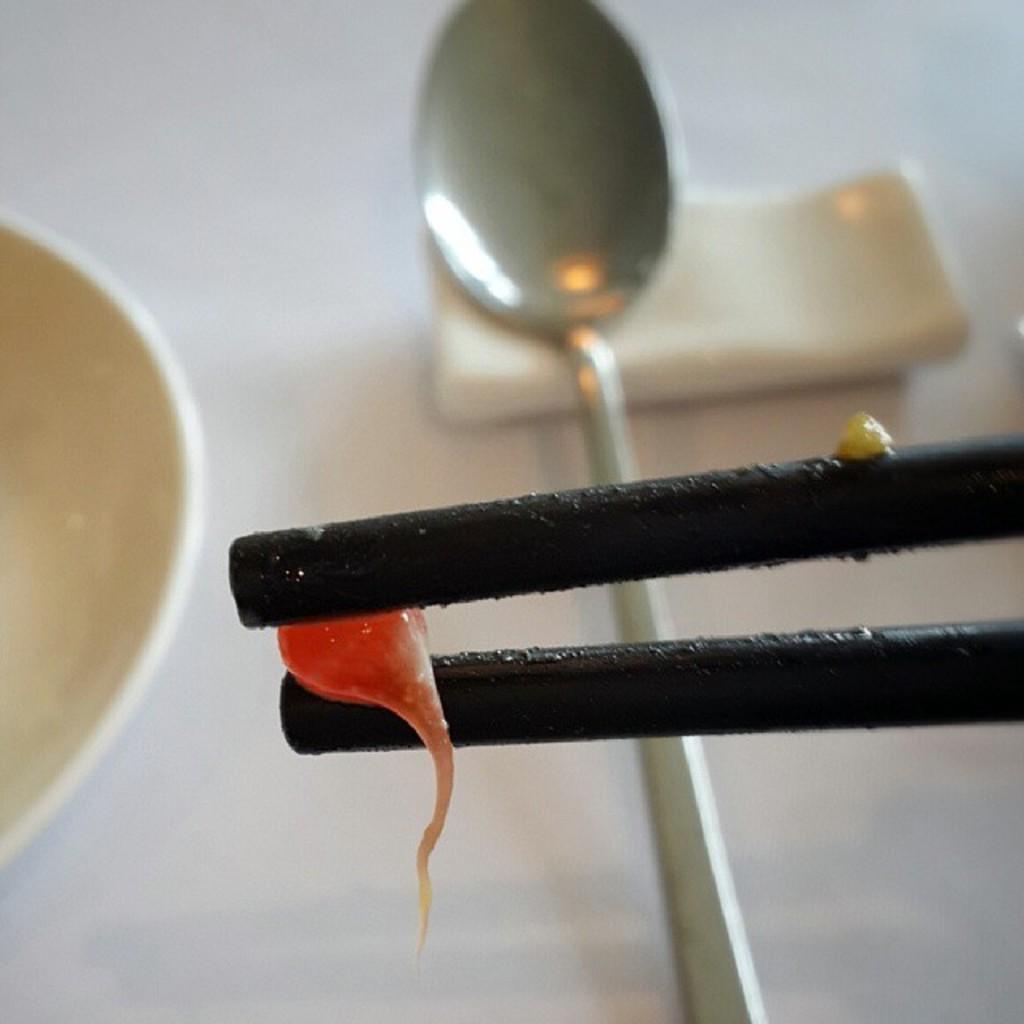In one or two sentences, can you explain what this image depicts? In this picture we can see a bowl, spoon, chopsticks and in between chop sticks we have a red color liquid bubble, tissue papers. 